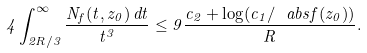<formula> <loc_0><loc_0><loc_500><loc_500>4 \int _ { 2 R / 3 } ^ { \infty } \frac { N _ { f } ( t , z _ { 0 } ) \, d t } { t ^ { 3 } } \leq 9 \frac { c _ { 2 } + \log ( c _ { 1 } / \ a b s { f ( z _ { 0 } ) } ) } { R } .</formula> 